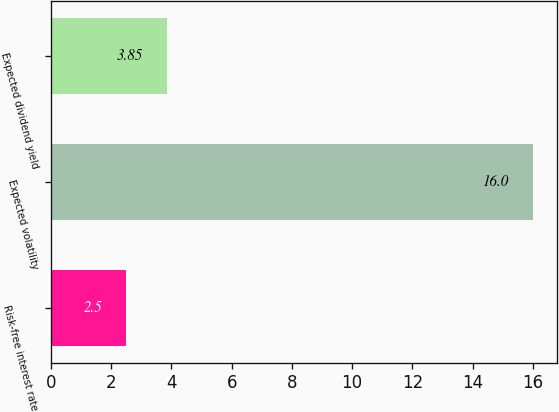Convert chart to OTSL. <chart><loc_0><loc_0><loc_500><loc_500><bar_chart><fcel>Risk-free interest rate<fcel>Expected volatility<fcel>Expected dividend yield<nl><fcel>2.5<fcel>16<fcel>3.85<nl></chart> 